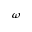<formula> <loc_0><loc_0><loc_500><loc_500>\omega</formula> 